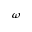<formula> <loc_0><loc_0><loc_500><loc_500>\omega</formula> 